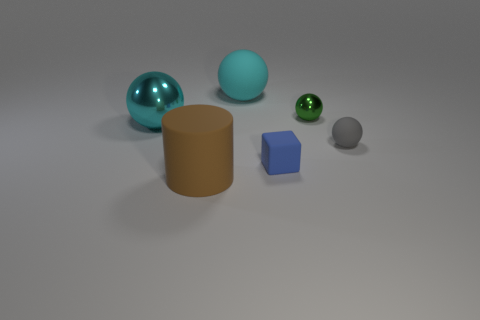What material is the brown object?
Make the answer very short. Rubber. There is a matte sphere that is on the left side of the blue matte object; is it the same size as the blue thing?
Your answer should be compact. No. There is a metallic object that is on the left side of the cyan matte thing; how big is it?
Provide a short and direct response. Large. How many tiny cyan cylinders are there?
Your answer should be compact. 0. Is the color of the big rubber ball the same as the big metallic ball?
Provide a succinct answer. Yes. What color is the ball that is in front of the green shiny object and on the left side of the green metal thing?
Provide a short and direct response. Cyan. There is a large cylinder; are there any cyan matte objects to the right of it?
Your answer should be very brief. Yes. How many cyan objects are in front of the large cyan object that is behind the tiny green thing?
Provide a succinct answer. 1. There is a gray object that is the same material as the brown cylinder; what size is it?
Make the answer very short. Small. How big is the blue block?
Your answer should be compact. Small. 